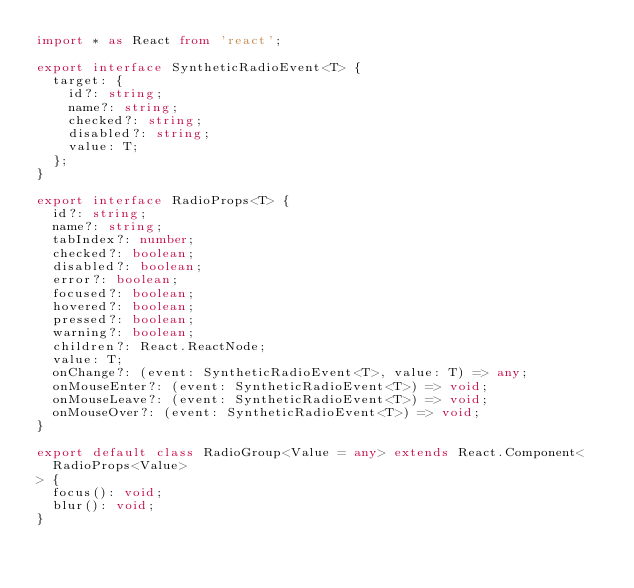<code> <loc_0><loc_0><loc_500><loc_500><_TypeScript_>import * as React from 'react';

export interface SyntheticRadioEvent<T> {
  target: {
    id?: string;
    name?: string;
    checked?: string;
    disabled?: string;
    value: T;
  };
}

export interface RadioProps<T> {
  id?: string;
  name?: string;
  tabIndex?: number;
  checked?: boolean;
  disabled?: boolean;
  error?: boolean;
  focused?: boolean;
  hovered?: boolean;
  pressed?: boolean;
  warning?: boolean;
  children?: React.ReactNode;
  value: T;
  onChange?: (event: SyntheticRadioEvent<T>, value: T) => any;
  onMouseEnter?: (event: SyntheticRadioEvent<T>) => void;
  onMouseLeave?: (event: SyntheticRadioEvent<T>) => void;
  onMouseOver?: (event: SyntheticRadioEvent<T>) => void;
}

export default class RadioGroup<Value = any> extends React.Component<
  RadioProps<Value>
> {
  focus(): void;
  blur(): void;
}
</code> 